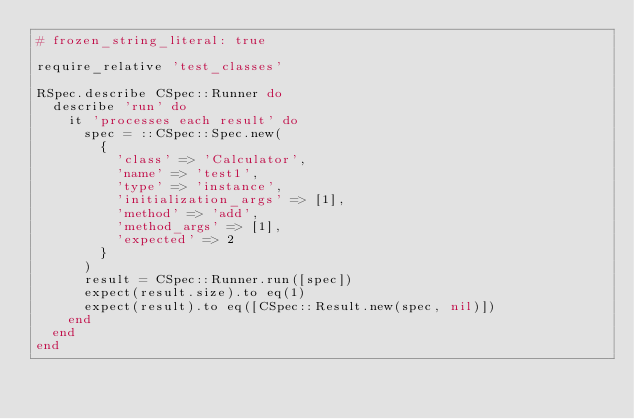<code> <loc_0><loc_0><loc_500><loc_500><_Ruby_># frozen_string_literal: true

require_relative 'test_classes'

RSpec.describe CSpec::Runner do
  describe 'run' do
    it 'processes each result' do
      spec = ::CSpec::Spec.new(
        {
          'class' => 'Calculator',
          'name' => 'test1',
          'type' => 'instance',
          'initialization_args' => [1],
          'method' => 'add',
          'method_args' => [1],
          'expected' => 2
        }
      )
      result = CSpec::Runner.run([spec])
      expect(result.size).to eq(1)
      expect(result).to eq([CSpec::Result.new(spec, nil)])
    end
  end
end
</code> 